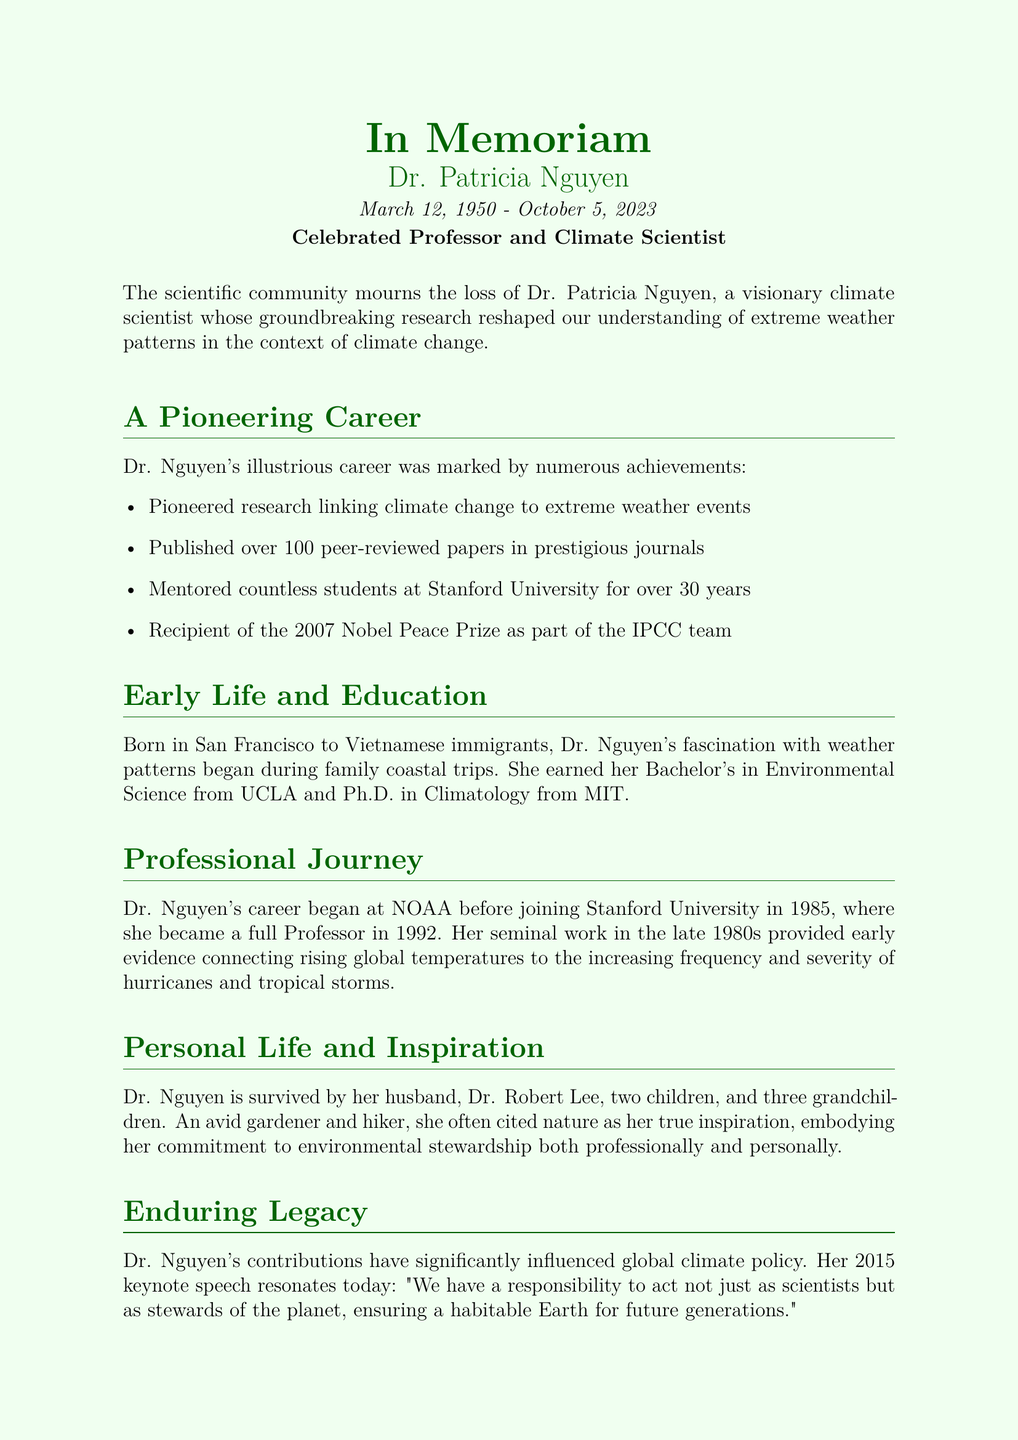What is Dr. Patricia Nguyen's birth date? Dr. Patricia Nguyen was born on March 12, 1950, as mentioned in the document.
Answer: March 12, 1950 What prestigious award did Dr. Nguyen receive in 2007? The document states that she was a recipient of the 2007 Nobel Peace Prize.
Answer: Nobel Peace Prize How many peer-reviewed papers did Dr. Nguyen publish? According to the document, Dr. Nguyen published over 100 peer-reviewed papers.
Answer: over 100 What university did Dr. Nguyen mentor students at? The document specifies that she mentored students at Stanford University for over 30 years.
Answer: Stanford University What was Dr. Nguyen's role in the IPCC team? The document indicates that she was part of the IPCC team that received the Nobel Peace Prize.
Answer: part of the IPCC team What inspired Dr. Nguyen's commitment to environmental stewardship? The document mentions that Dr. Nguyen often cited nature as her true inspiration.
Answer: nature What year did Dr. Nguyen achieve the title of full Professor? According to the document, Dr. Nguyen became a full Professor in 1992.
Answer: 1992 How many grandchildren did Dr. Nguyen have? The document states that she is survived by three grandchildren.
Answer: three grandchildren What was Dr. Nguyen’s field of Ph.D. study? The document indicates that Dr. Nguyen earned a Ph.D. in Climatology.
Answer: Climatology 